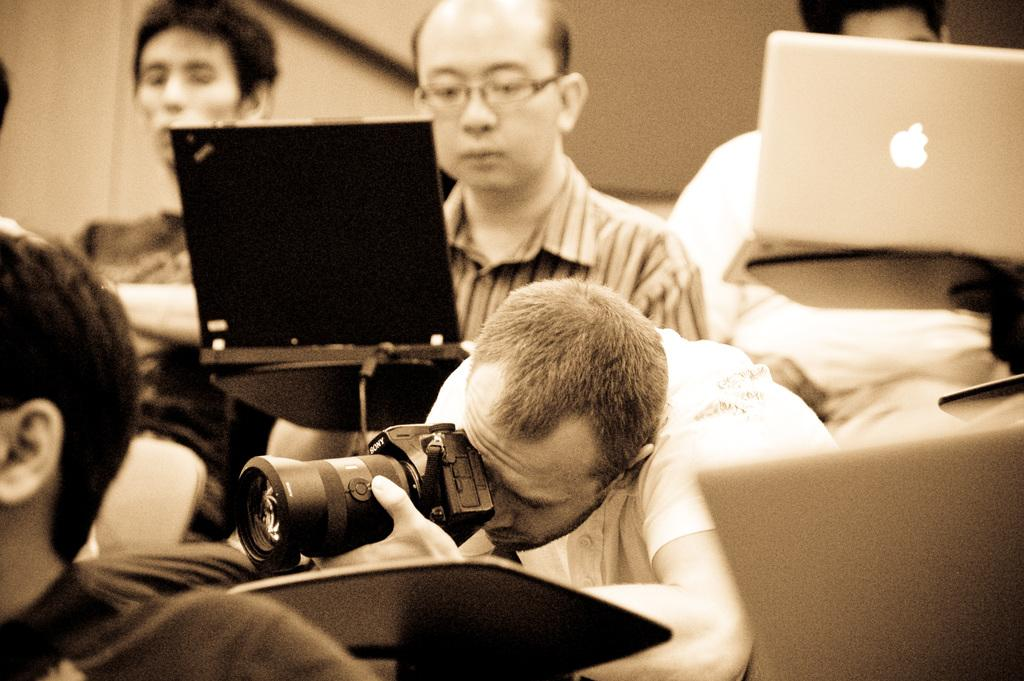What is the person in the foreground of the image doing? The person is holding a camera in the image. Can you describe the people in the background of the image? There are people in the background of the image, and at least two of them are using laptops. What type of pen is the person using to write their lunch order in the image? There is no pen or lunch order present in the image; the person is holding a camera, and there are people in the background using laptops. 